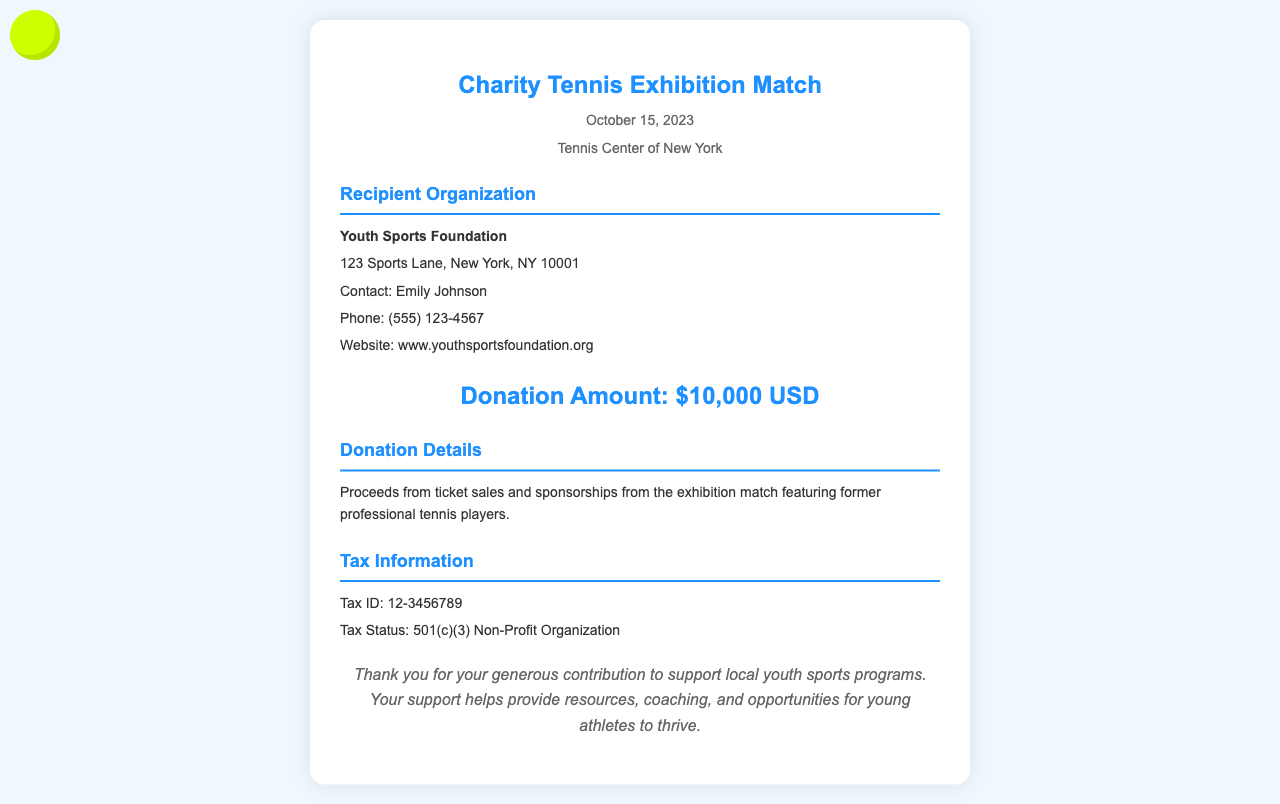What is the donation amount? The document specifically states the donation amount made during the event, which is highlighted in a section.
Answer: $10,000 USD Who is the recipient organization? The document contains a section that identifies the organization that received the donation.
Answer: Youth Sports Foundation When was the charity event held? The date of the charity event is mentioned in the header of the document.
Answer: October 15, 2023 What is the tax status of the recipient organization? The tax status is provided in the tax information section of the receipt.
Answer: 501(c)(3) Non-Profit Organization Who is the contact person for the recipient organization? The document includes details about the contact person associated with the recipient organization.
Answer: Emily Johnson What type of event was held? The nature of the event is specified in the header of the document.
Answer: Charity Tennis Exhibition Match What was the source of the donation proceeds? The document explains how the donation amount was generated through the event.
Answer: Proceeds from ticket sales and sponsorships What is the contact number for the organization? The document lists a contact number for the recipient organization for further inquiries.
Answer: (555) 123-4567 What is the address of the Youth Sports Foundation? The address is provided in the details section dedicated to the recipient organization.
Answer: 123 Sports Lane, New York, NY 10001 